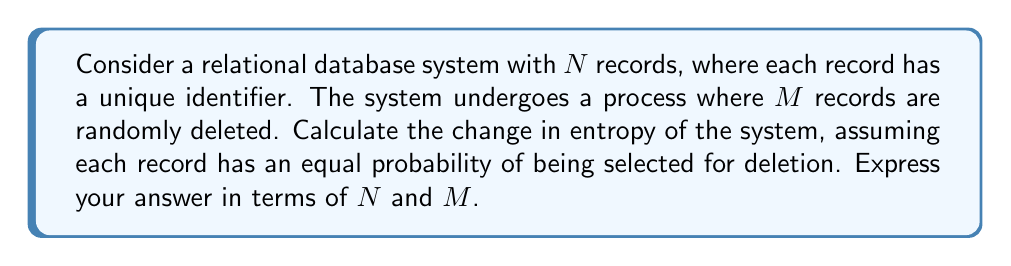Could you help me with this problem? Let's approach this step-by-step:

1) Initially, the entropy of the system can be calculated using the Shannon entropy formula:
   $$S_i = -k \sum_{i=1}^N p_i \ln p_i$$
   where $k$ is Boltzmann's constant (which we can set to 1 for simplicity), and $p_i$ is the probability of each state.

2) Since each record has an equal probability, $p_i = \frac{1}{N}$ for all $i$. Thus:
   $$S_i = -\sum_{i=1}^N \frac{1}{N} \ln \frac{1}{N} = -N \cdot \frac{1}{N} \ln \frac{1}{N} = \ln N$$

3) After deleting $M$ records, we have $N-M$ records left, each with probability $\frac{1}{N-M}$. The new entropy is:
   $$S_f = \ln (N-M)$$

4) The change in entropy is the difference between the final and initial entropies:
   $$\Delta S = S_f - S_i = \ln (N-M) - \ln N$$

5) Using the properties of logarithms, we can simplify this to:
   $$\Delta S = \ln \frac{N-M}{N}$$

This represents the decrease in entropy due to the deletion of records, as the system becomes more ordered (fewer possible states).
Answer: $\ln \frac{N-M}{N}$ 